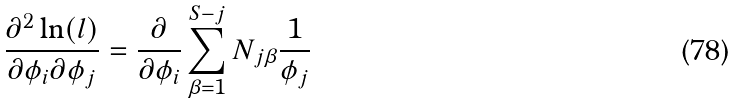<formula> <loc_0><loc_0><loc_500><loc_500>\frac { \partial ^ { 2 } \ln ( l ) } { \partial \phi _ { i } \partial \phi _ { j } } = \frac { \partial } { \partial \phi _ { i } } \sum _ { \beta = 1 } ^ { S - j } N _ { j \beta } \frac { 1 } { \phi _ { j } }</formula> 